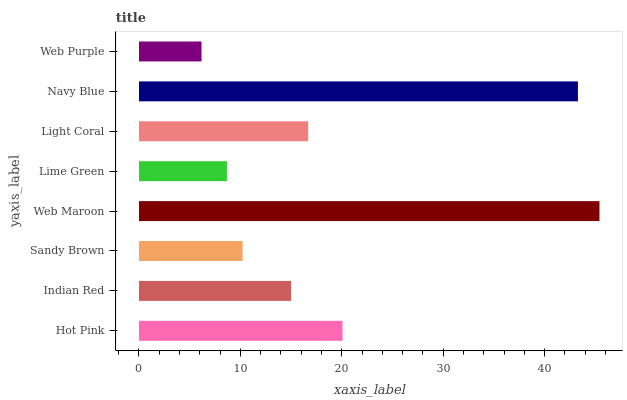Is Web Purple the minimum?
Answer yes or no. Yes. Is Web Maroon the maximum?
Answer yes or no. Yes. Is Indian Red the minimum?
Answer yes or no. No. Is Indian Red the maximum?
Answer yes or no. No. Is Hot Pink greater than Indian Red?
Answer yes or no. Yes. Is Indian Red less than Hot Pink?
Answer yes or no. Yes. Is Indian Red greater than Hot Pink?
Answer yes or no. No. Is Hot Pink less than Indian Red?
Answer yes or no. No. Is Light Coral the high median?
Answer yes or no. Yes. Is Indian Red the low median?
Answer yes or no. Yes. Is Sandy Brown the high median?
Answer yes or no. No. Is Light Coral the low median?
Answer yes or no. No. 